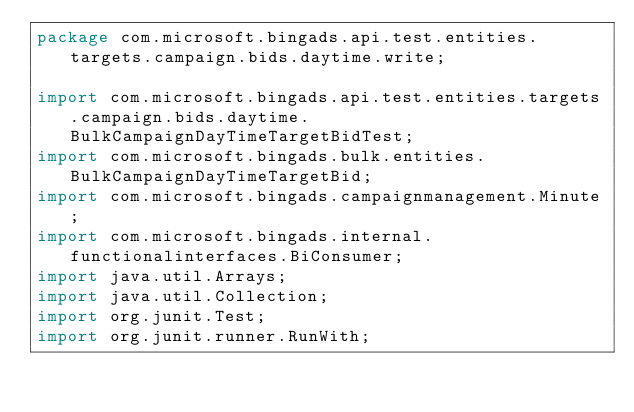<code> <loc_0><loc_0><loc_500><loc_500><_Java_>package com.microsoft.bingads.api.test.entities.targets.campaign.bids.daytime.write;

import com.microsoft.bingads.api.test.entities.targets.campaign.bids.daytime.BulkCampaignDayTimeTargetBidTest;
import com.microsoft.bingads.bulk.entities.BulkCampaignDayTimeTargetBid;
import com.microsoft.bingads.campaignmanagement.Minute;
import com.microsoft.bingads.internal.functionalinterfaces.BiConsumer;
import java.util.Arrays;
import java.util.Collection;
import org.junit.Test;
import org.junit.runner.RunWith;</code> 